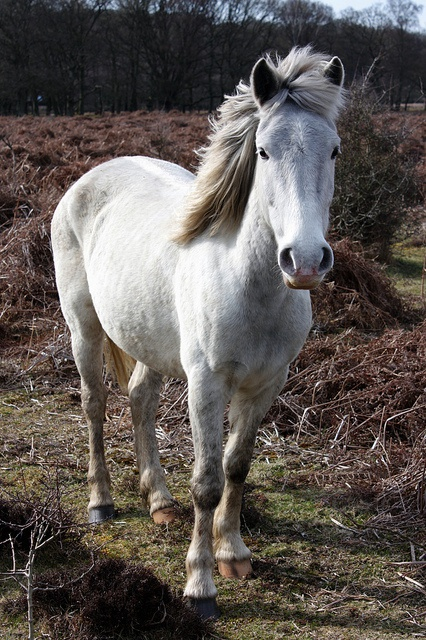Describe the objects in this image and their specific colors. I can see a horse in black, lightgray, gray, and darkgray tones in this image. 